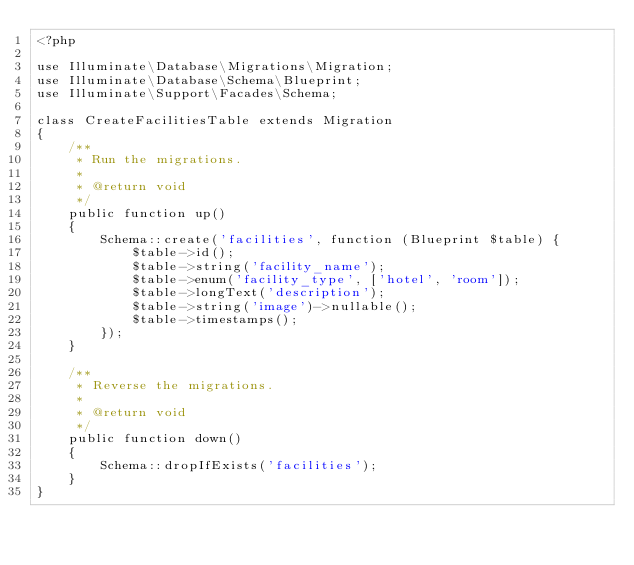<code> <loc_0><loc_0><loc_500><loc_500><_PHP_><?php

use Illuminate\Database\Migrations\Migration;
use Illuminate\Database\Schema\Blueprint;
use Illuminate\Support\Facades\Schema;

class CreateFacilitiesTable extends Migration
{
    /**
     * Run the migrations.
     *
     * @return void
     */
    public function up()
    {
        Schema::create('facilities', function (Blueprint $table) {
            $table->id();
            $table->string('facility_name');
            $table->enum('facility_type', ['hotel', 'room']);
            $table->longText('description');
            $table->string('image')->nullable();
            $table->timestamps();
        });
    }

    /**
     * Reverse the migrations.
     *
     * @return void
     */
    public function down()
    {
        Schema::dropIfExists('facilities');
    }
}
</code> 